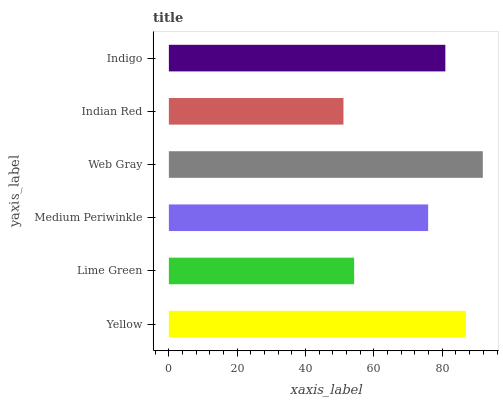Is Indian Red the minimum?
Answer yes or no. Yes. Is Web Gray the maximum?
Answer yes or no. Yes. Is Lime Green the minimum?
Answer yes or no. No. Is Lime Green the maximum?
Answer yes or no. No. Is Yellow greater than Lime Green?
Answer yes or no. Yes. Is Lime Green less than Yellow?
Answer yes or no. Yes. Is Lime Green greater than Yellow?
Answer yes or no. No. Is Yellow less than Lime Green?
Answer yes or no. No. Is Indigo the high median?
Answer yes or no. Yes. Is Medium Periwinkle the low median?
Answer yes or no. Yes. Is Yellow the high median?
Answer yes or no. No. Is Lime Green the low median?
Answer yes or no. No. 